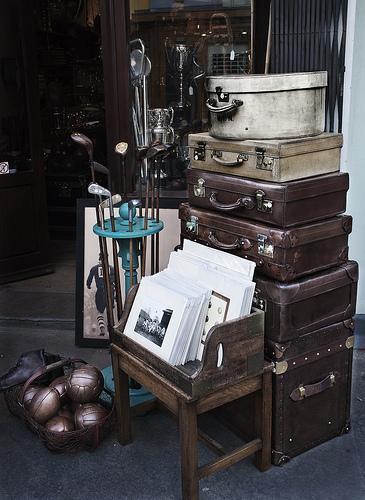How many cases are stacked up?
Give a very brief answer. 6. How many light suitcases are there?
Give a very brief answer. 2. How many pieces of luggage are round?
Give a very brief answer. 1. 